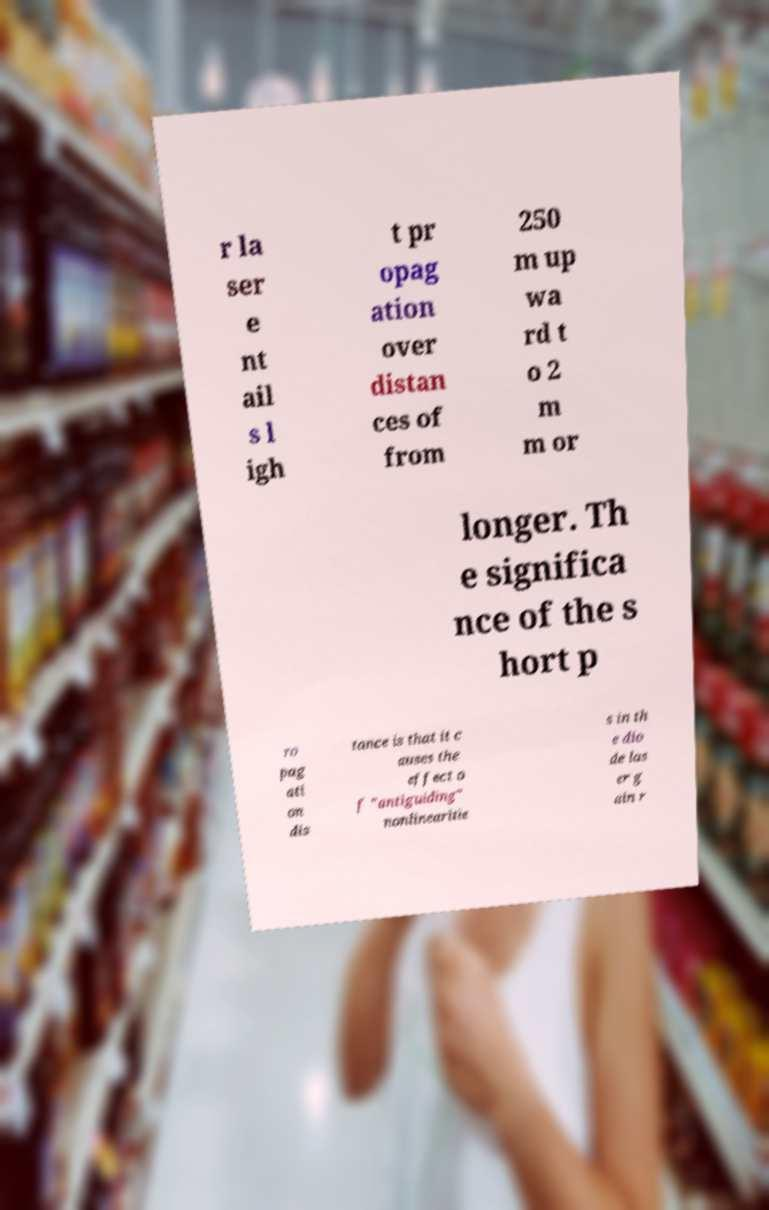Can you accurately transcribe the text from the provided image for me? r la ser e nt ail s l igh t pr opag ation over distan ces of from 250 m up wa rd t o 2 m m or longer. Th e significa nce of the s hort p ro pag ati on dis tance is that it c auses the effect o f "antiguiding" nonlinearitie s in th e dio de las er g ain r 